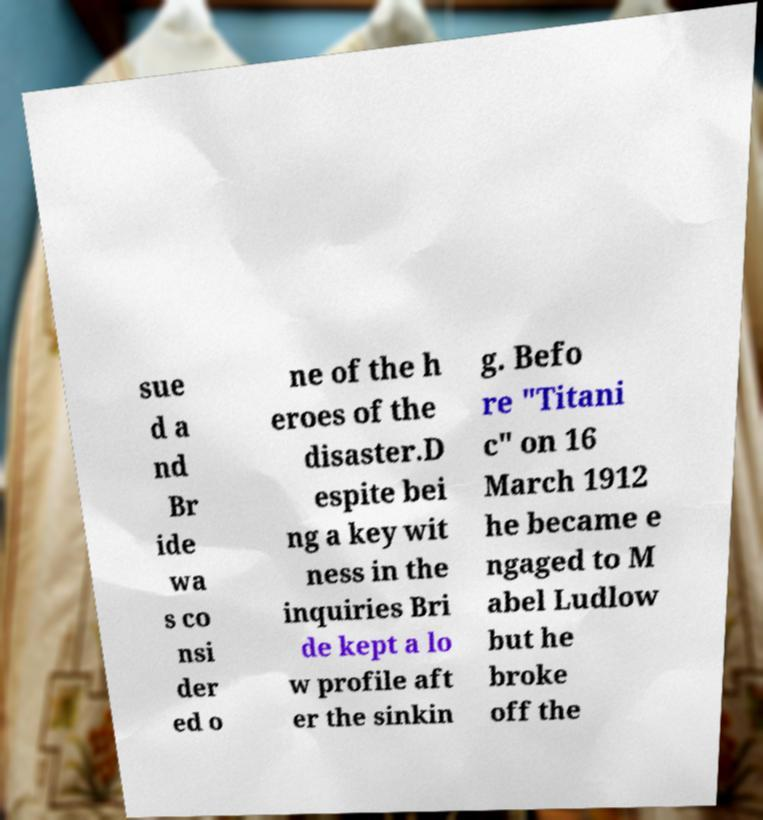Can you accurately transcribe the text from the provided image for me? sue d a nd Br ide wa s co nsi der ed o ne of the h eroes of the disaster.D espite bei ng a key wit ness in the inquiries Bri de kept a lo w profile aft er the sinkin g. Befo re "Titani c" on 16 March 1912 he became e ngaged to M abel Ludlow but he broke off the 